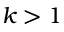Convert formula to latex. <formula><loc_0><loc_0><loc_500><loc_500>k > 1</formula> 